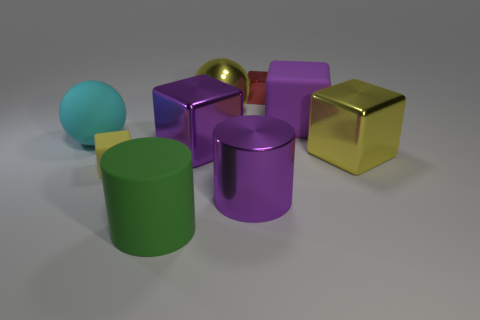Is there anything else that is the same color as the large metallic cylinder?
Your response must be concise. Yes. Does the large cyan matte object that is left of the red shiny object have the same shape as the metal object in front of the small yellow object?
Offer a terse response. No. What number of objects are either brown matte blocks or cubes behind the rubber ball?
Offer a terse response. 2. What number of other things are the same size as the red metallic thing?
Ensure brevity in your answer.  1. Does the yellow object that is behind the big cyan object have the same material as the large purple object that is in front of the yellow rubber thing?
Your response must be concise. Yes. There is a tiny red metal object; how many big things are to the left of it?
Provide a short and direct response. 5. What number of yellow things are big cylinders or large shiny spheres?
Offer a terse response. 1. What is the material of the yellow block that is the same size as the red object?
Your answer should be very brief. Rubber. What shape is the object that is both in front of the large metal sphere and behind the large cyan rubber thing?
Your response must be concise. Cube. There is another object that is the same size as the yellow matte object; what is its color?
Provide a succinct answer. Red. 